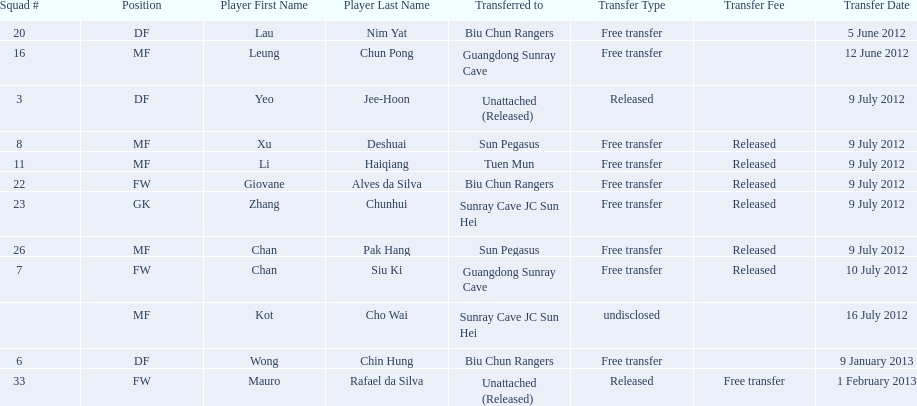Who is the first player listed? Lau Nim Yat. 